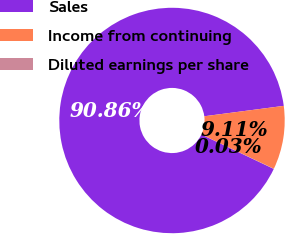Convert chart to OTSL. <chart><loc_0><loc_0><loc_500><loc_500><pie_chart><fcel>Sales<fcel>Income from continuing<fcel>Diluted earnings per share<nl><fcel>90.85%<fcel>9.11%<fcel>0.03%<nl></chart> 